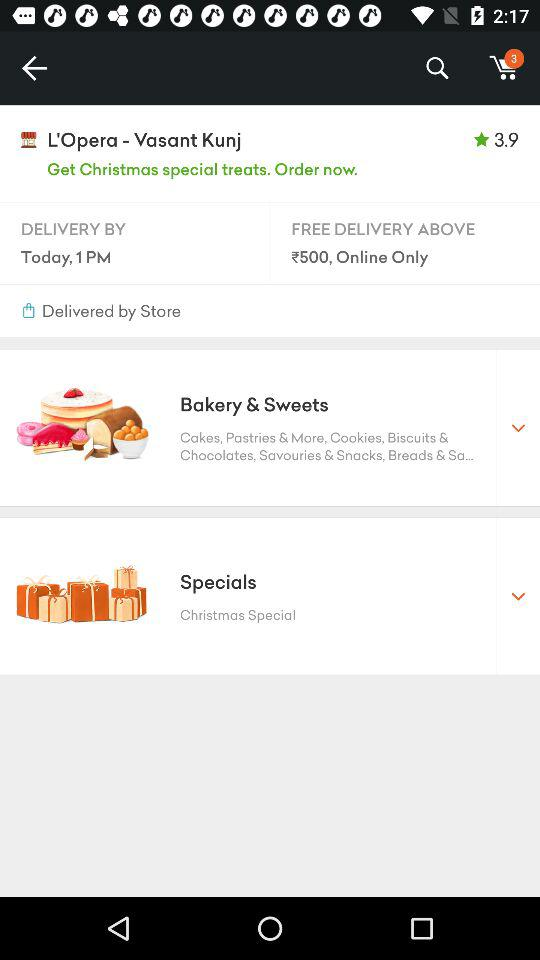By whom should it be delivered? It should be delivered by "L'Opera" store. 